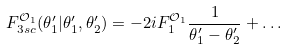<formula> <loc_0><loc_0><loc_500><loc_500>F _ { 3 s c } ^ { \mathcal { O } _ { 1 } } ( \theta ^ { \prime } _ { 1 } | \theta ^ { \prime } _ { 1 } , \theta ^ { \prime } _ { 2 } ) = - 2 i F _ { 1 } ^ { \mathcal { O } _ { 1 } } \frac { 1 } { \theta ^ { \prime } _ { 1 } - \theta ^ { \prime } _ { 2 } } + \dots</formula> 